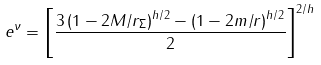<formula> <loc_0><loc_0><loc_500><loc_500>e ^ { \nu } = \left [ \frac { 3 \left ( 1 - 2 M / r _ { \Sigma } \right ) ^ { h / 2 } - \left ( 1 - 2 m / r \right ) ^ { h / 2 } } { 2 } \right ] ^ { 2 / h }</formula> 